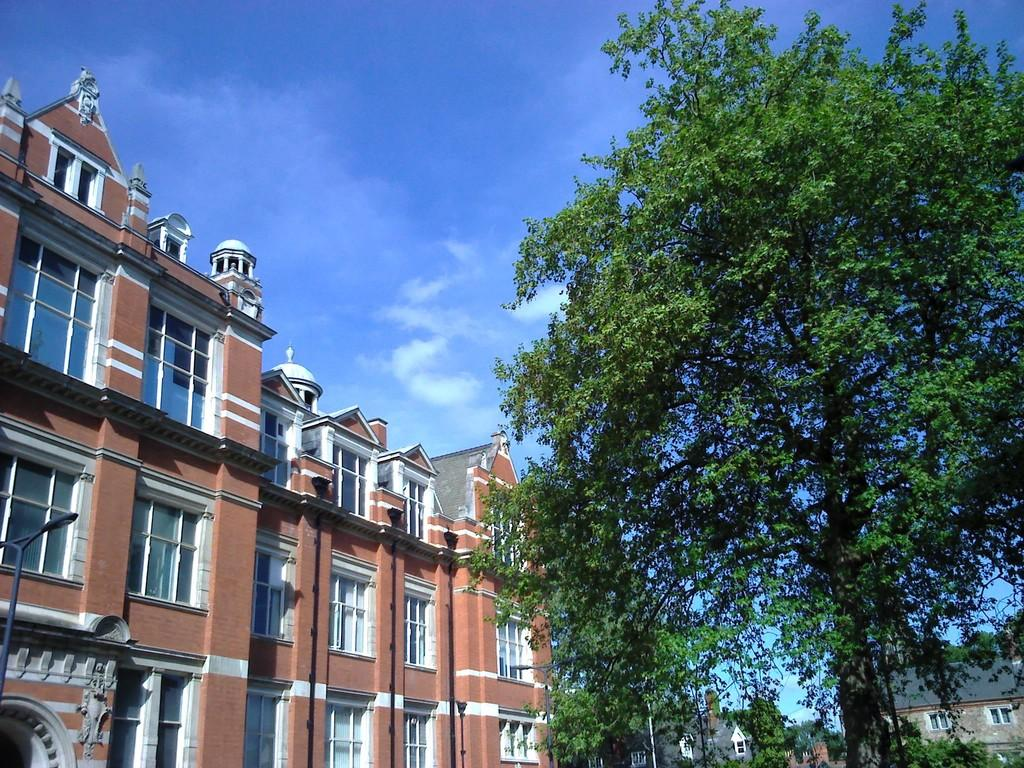What type of vegetation is present in the image? There are trees in the image. What color are the trees? The trees are green. What can be seen in the background of the image? There are buildings in the background of the image. What colors are the buildings? The buildings are brown and gray. What is visible in the sky in the image? The sky is blue and white. What type of underwear is hanging on the trees in the image? There is no underwear present in the image; it only features trees, buildings, and the sky. 